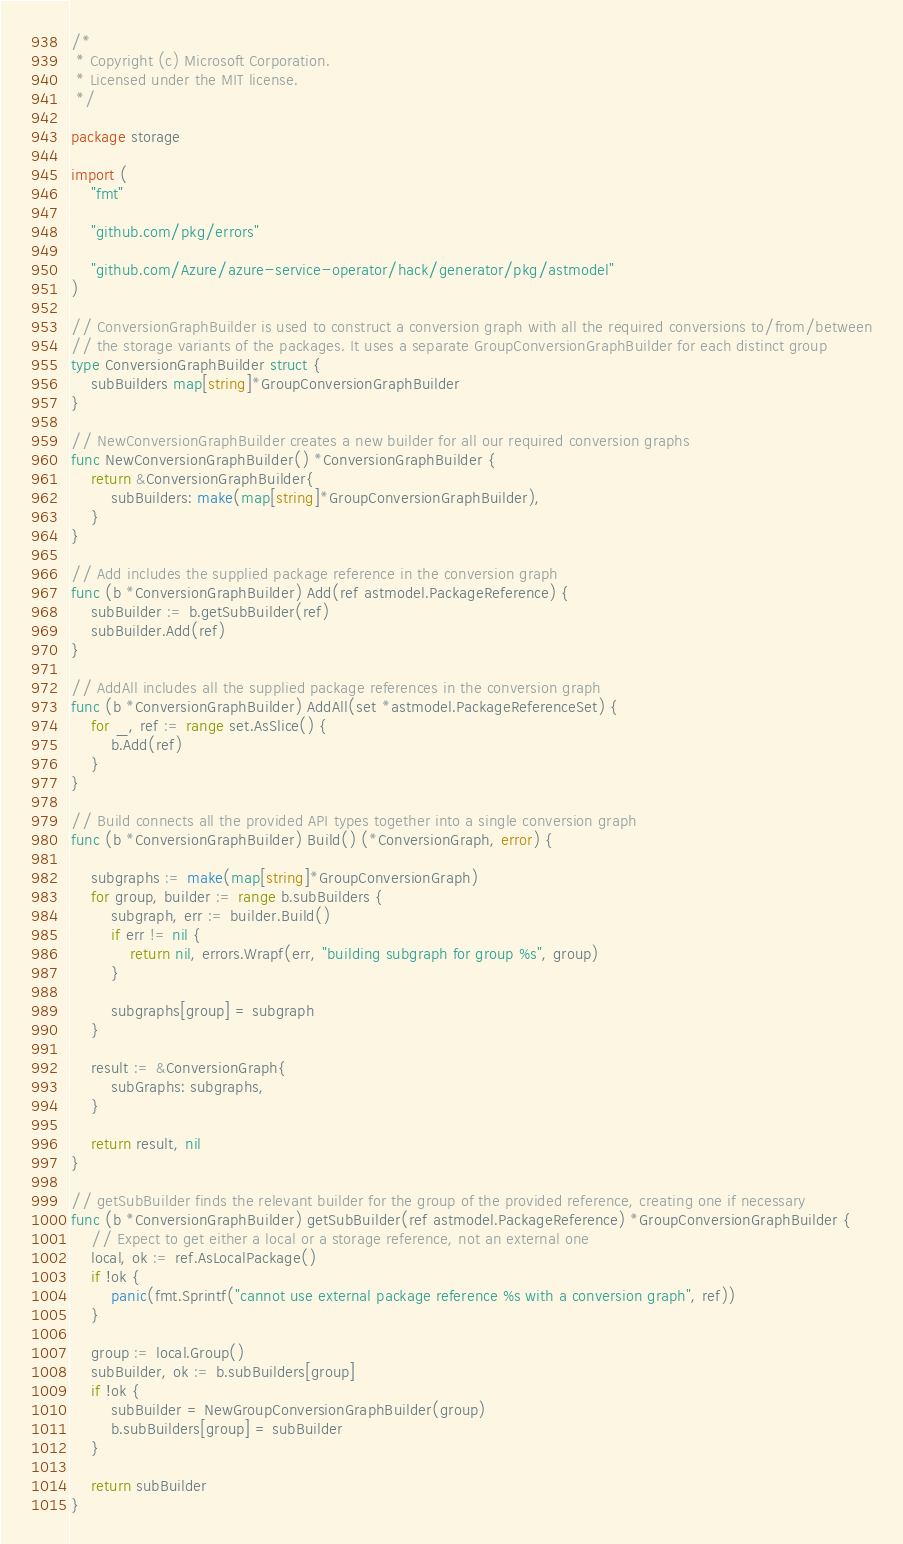Convert code to text. <code><loc_0><loc_0><loc_500><loc_500><_Go_>/*
 * Copyright (c) Microsoft Corporation.
 * Licensed under the MIT license.
 */

package storage

import (
	"fmt"

	"github.com/pkg/errors"

	"github.com/Azure/azure-service-operator/hack/generator/pkg/astmodel"
)

// ConversionGraphBuilder is used to construct a conversion graph with all the required conversions to/from/between
// the storage variants of the packages. It uses a separate GroupConversionGraphBuilder for each distinct group
type ConversionGraphBuilder struct {
	subBuilders map[string]*GroupConversionGraphBuilder
}

// NewConversionGraphBuilder creates a new builder for all our required conversion graphs
func NewConversionGraphBuilder() *ConversionGraphBuilder {
	return &ConversionGraphBuilder{
		subBuilders: make(map[string]*GroupConversionGraphBuilder),
	}
}

// Add includes the supplied package reference in the conversion graph
func (b *ConversionGraphBuilder) Add(ref astmodel.PackageReference) {
	subBuilder := b.getSubBuilder(ref)
	subBuilder.Add(ref)
}

// AddAll includes all the supplied package references in the conversion graph
func (b *ConversionGraphBuilder) AddAll(set *astmodel.PackageReferenceSet) {
	for _, ref := range set.AsSlice() {
		b.Add(ref)
	}
}

// Build connects all the provided API types together into a single conversion graph
func (b *ConversionGraphBuilder) Build() (*ConversionGraph, error) {

	subgraphs := make(map[string]*GroupConversionGraph)
	for group, builder := range b.subBuilders {
		subgraph, err := builder.Build()
		if err != nil {
			return nil, errors.Wrapf(err, "building subgraph for group %s", group)
		}

		subgraphs[group] = subgraph
	}

	result := &ConversionGraph{
		subGraphs: subgraphs,
	}

	return result, nil
}

// getSubBuilder finds the relevant builder for the group of the provided reference, creating one if necessary
func (b *ConversionGraphBuilder) getSubBuilder(ref astmodel.PackageReference) *GroupConversionGraphBuilder {
	// Expect to get either a local or a storage reference, not an external one
	local, ok := ref.AsLocalPackage()
	if !ok {
		panic(fmt.Sprintf("cannot use external package reference %s with a conversion graph", ref))
	}

	group := local.Group()
	subBuilder, ok := b.subBuilders[group]
	if !ok {
		subBuilder = NewGroupConversionGraphBuilder(group)
		b.subBuilders[group] = subBuilder
	}

	return subBuilder
}
</code> 